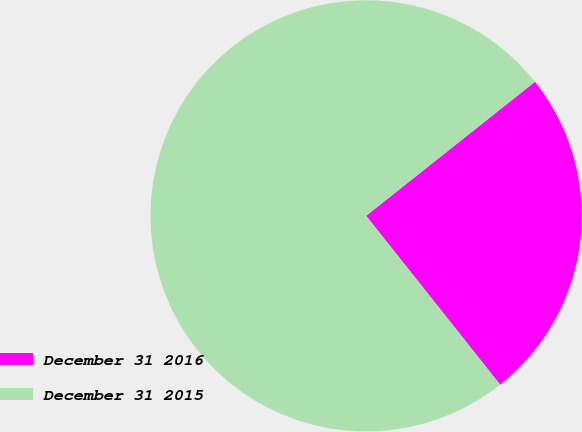Convert chart to OTSL. <chart><loc_0><loc_0><loc_500><loc_500><pie_chart><fcel>December 31 2016<fcel>December 31 2015<nl><fcel>25.0%<fcel>75.0%<nl></chart> 